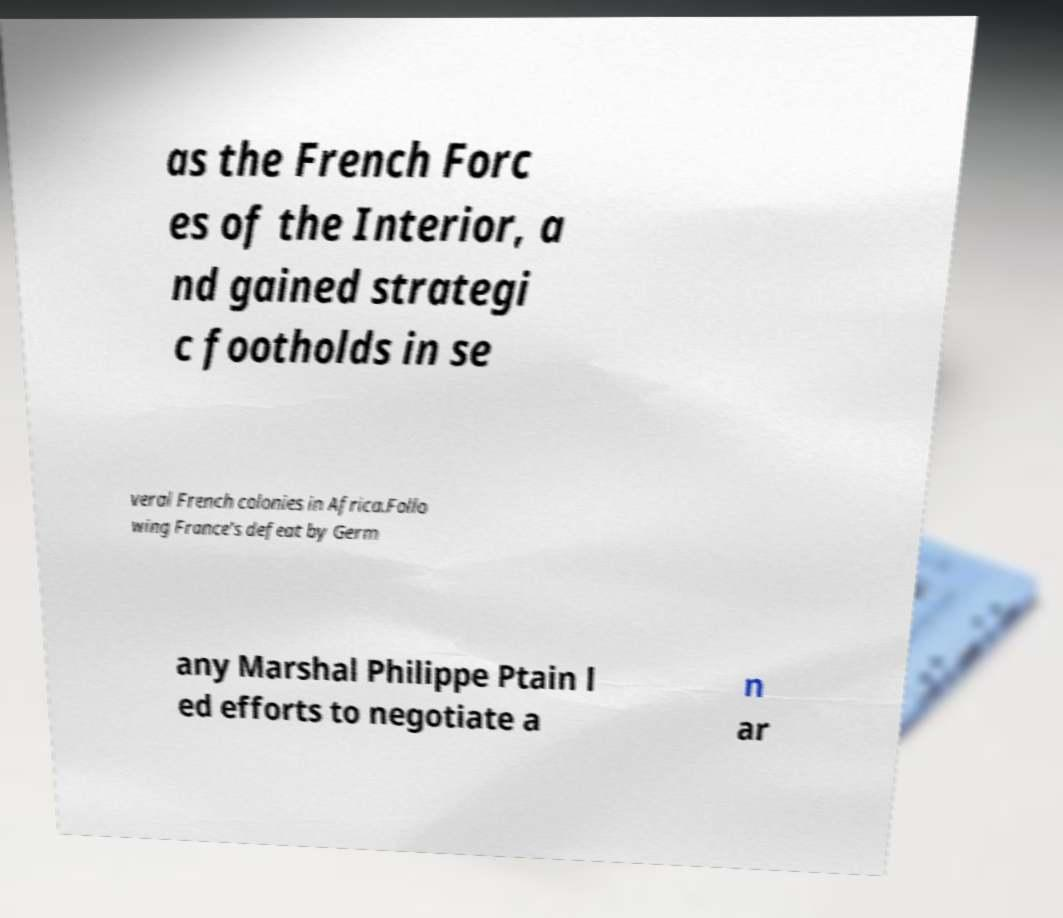Could you extract and type out the text from this image? as the French Forc es of the Interior, a nd gained strategi c footholds in se veral French colonies in Africa.Follo wing France's defeat by Germ any Marshal Philippe Ptain l ed efforts to negotiate a n ar 